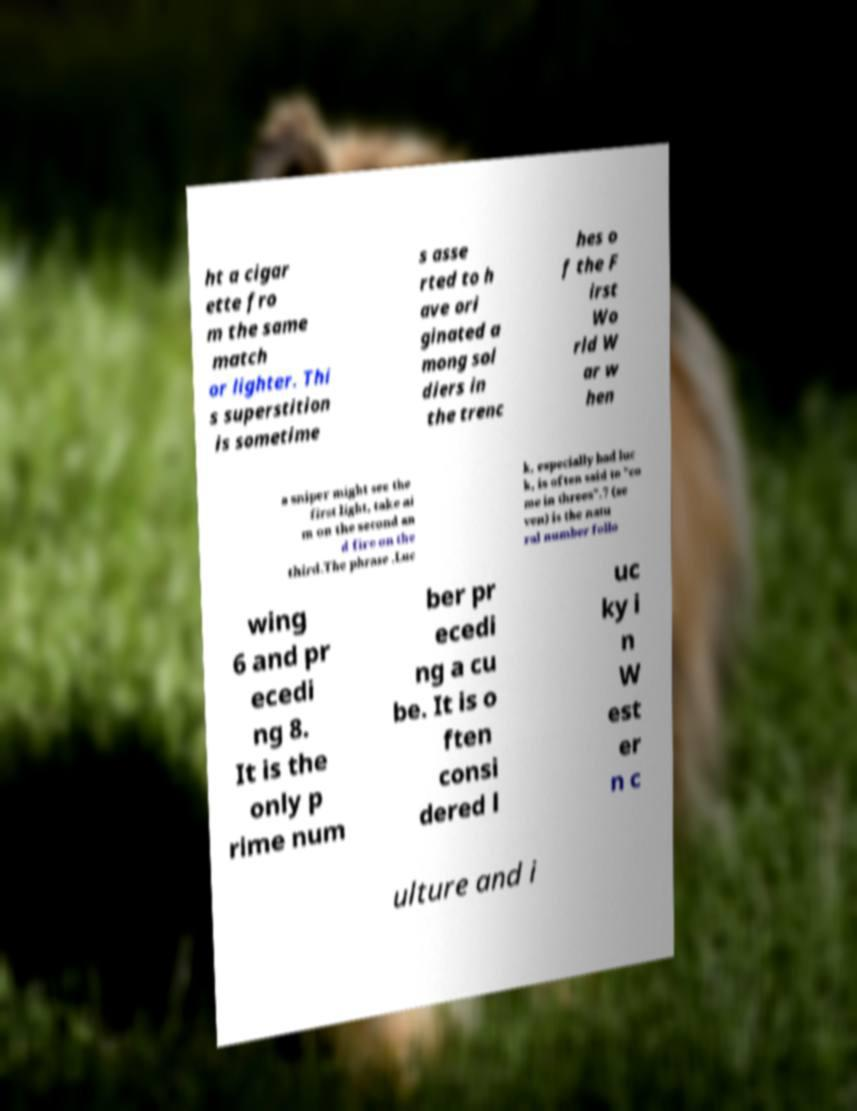Could you extract and type out the text from this image? ht a cigar ette fro m the same match or lighter. Thi s superstition is sometime s asse rted to h ave ori ginated a mong sol diers in the trenc hes o f the F irst Wo rld W ar w hen a sniper might see the first light, take ai m on the second an d fire on the third.The phrase .Luc k, especially bad luc k, is often said to "co me in threes".7 (se ven) is the natu ral number follo wing 6 and pr ecedi ng 8. It is the only p rime num ber pr ecedi ng a cu be. It is o ften consi dered l uc ky i n W est er n c ulture and i 